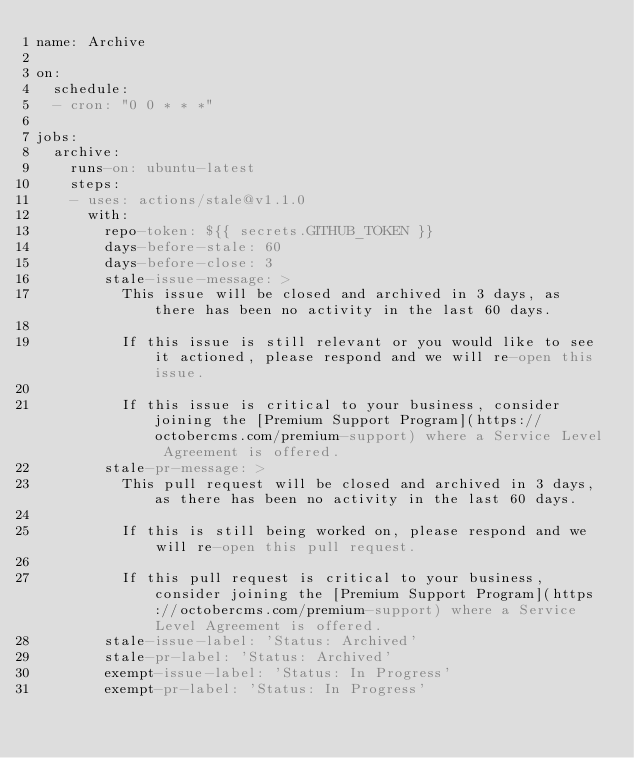<code> <loc_0><loc_0><loc_500><loc_500><_YAML_>name: Archive

on:
  schedule:
  - cron: "0 0 * * *"

jobs:
  archive:
    runs-on: ubuntu-latest
    steps:
    - uses: actions/stale@v1.1.0
      with:
        repo-token: ${{ secrets.GITHUB_TOKEN }}
        days-before-stale: 60
        days-before-close: 3
        stale-issue-message: >
          This issue will be closed and archived in 3 days, as there has been no activity in the last 60 days.

          If this issue is still relevant or you would like to see it actioned, please respond and we will re-open this issue.
          
          If this issue is critical to your business, consider joining the [Premium Support Program](https://octobercms.com/premium-support) where a Service Level Agreement is offered.
        stale-pr-message: >
          This pull request will be closed and archived in 3 days, as there has been no activity in the last 60 days.

          If this is still being worked on, please respond and we will re-open this pull request.
          
          If this pull request is critical to your business, consider joining the [Premium Support Program](https://octobercms.com/premium-support) where a Service Level Agreement is offered.
        stale-issue-label: 'Status: Archived'
        stale-pr-label: 'Status: Archived'
        exempt-issue-label: 'Status: In Progress'
        exempt-pr-label: 'Status: In Progress'</code> 